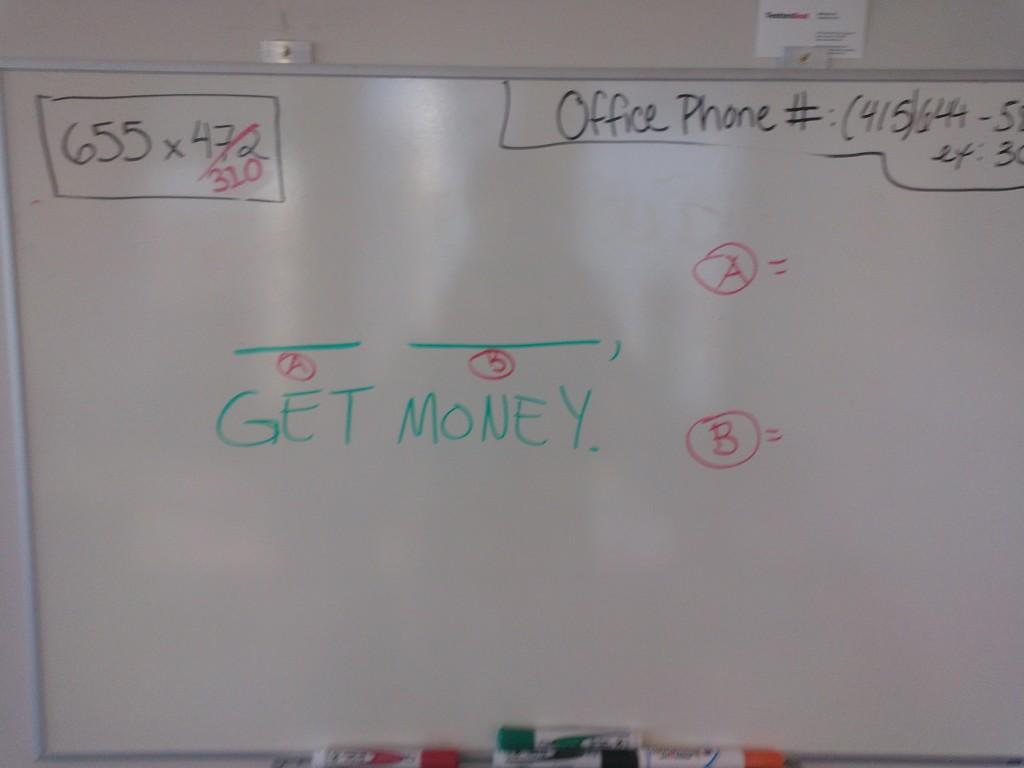What room is shown for the phone number?
Make the answer very short. Office. 